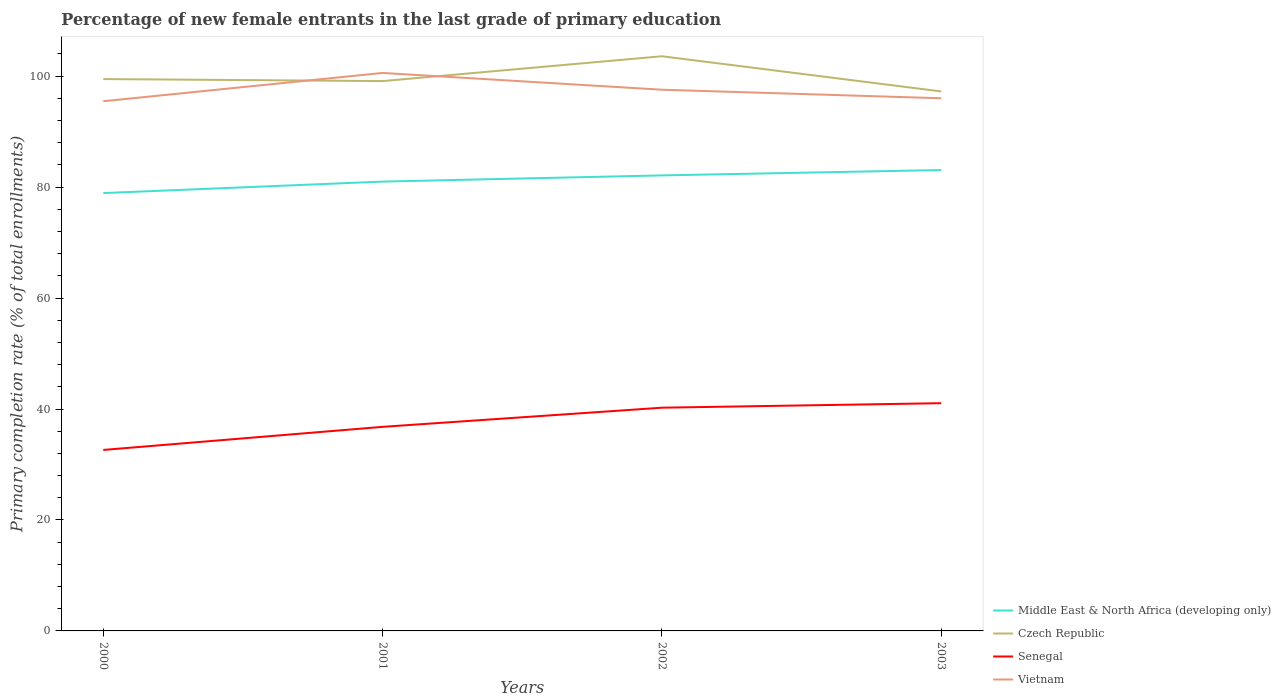How many different coloured lines are there?
Make the answer very short. 4. Is the number of lines equal to the number of legend labels?
Your response must be concise. Yes. Across all years, what is the maximum percentage of new female entrants in Czech Republic?
Offer a very short reply. 97.24. What is the total percentage of new female entrants in Vietnam in the graph?
Your response must be concise. -0.54. What is the difference between the highest and the second highest percentage of new female entrants in Senegal?
Your answer should be compact. 8.43. What is the difference between the highest and the lowest percentage of new female entrants in Senegal?
Your response must be concise. 2. How many lines are there?
Your answer should be compact. 4. How many years are there in the graph?
Your answer should be compact. 4. What is the difference between two consecutive major ticks on the Y-axis?
Your response must be concise. 20. Are the values on the major ticks of Y-axis written in scientific E-notation?
Your response must be concise. No. Does the graph contain any zero values?
Keep it short and to the point. No. What is the title of the graph?
Keep it short and to the point. Percentage of new female entrants in the last grade of primary education. Does "Northern Mariana Islands" appear as one of the legend labels in the graph?
Provide a short and direct response. No. What is the label or title of the X-axis?
Your answer should be very brief. Years. What is the label or title of the Y-axis?
Offer a very short reply. Primary completion rate (% of total enrollments). What is the Primary completion rate (% of total enrollments) in Middle East & North Africa (developing only) in 2000?
Ensure brevity in your answer.  78.92. What is the Primary completion rate (% of total enrollments) in Czech Republic in 2000?
Offer a terse response. 99.47. What is the Primary completion rate (% of total enrollments) of Senegal in 2000?
Keep it short and to the point. 32.62. What is the Primary completion rate (% of total enrollments) in Vietnam in 2000?
Your answer should be compact. 95.48. What is the Primary completion rate (% of total enrollments) of Middle East & North Africa (developing only) in 2001?
Provide a succinct answer. 80.99. What is the Primary completion rate (% of total enrollments) of Czech Republic in 2001?
Keep it short and to the point. 99.11. What is the Primary completion rate (% of total enrollments) of Senegal in 2001?
Provide a short and direct response. 36.78. What is the Primary completion rate (% of total enrollments) in Vietnam in 2001?
Your response must be concise. 100.58. What is the Primary completion rate (% of total enrollments) in Middle East & North Africa (developing only) in 2002?
Your response must be concise. 82.11. What is the Primary completion rate (% of total enrollments) of Czech Republic in 2002?
Ensure brevity in your answer.  103.58. What is the Primary completion rate (% of total enrollments) in Senegal in 2002?
Ensure brevity in your answer.  40.24. What is the Primary completion rate (% of total enrollments) of Vietnam in 2002?
Provide a succinct answer. 97.55. What is the Primary completion rate (% of total enrollments) in Middle East & North Africa (developing only) in 2003?
Provide a short and direct response. 83.07. What is the Primary completion rate (% of total enrollments) in Czech Republic in 2003?
Your answer should be compact. 97.24. What is the Primary completion rate (% of total enrollments) of Senegal in 2003?
Your answer should be very brief. 41.05. What is the Primary completion rate (% of total enrollments) in Vietnam in 2003?
Offer a terse response. 96.01. Across all years, what is the maximum Primary completion rate (% of total enrollments) in Middle East & North Africa (developing only)?
Keep it short and to the point. 83.07. Across all years, what is the maximum Primary completion rate (% of total enrollments) of Czech Republic?
Your response must be concise. 103.58. Across all years, what is the maximum Primary completion rate (% of total enrollments) of Senegal?
Offer a terse response. 41.05. Across all years, what is the maximum Primary completion rate (% of total enrollments) in Vietnam?
Your answer should be compact. 100.58. Across all years, what is the minimum Primary completion rate (% of total enrollments) in Middle East & North Africa (developing only)?
Make the answer very short. 78.92. Across all years, what is the minimum Primary completion rate (% of total enrollments) in Czech Republic?
Provide a succinct answer. 97.24. Across all years, what is the minimum Primary completion rate (% of total enrollments) in Senegal?
Your answer should be very brief. 32.62. Across all years, what is the minimum Primary completion rate (% of total enrollments) in Vietnam?
Your answer should be very brief. 95.48. What is the total Primary completion rate (% of total enrollments) of Middle East & North Africa (developing only) in the graph?
Keep it short and to the point. 325.1. What is the total Primary completion rate (% of total enrollments) in Czech Republic in the graph?
Make the answer very short. 399.41. What is the total Primary completion rate (% of total enrollments) in Senegal in the graph?
Make the answer very short. 150.69. What is the total Primary completion rate (% of total enrollments) in Vietnam in the graph?
Ensure brevity in your answer.  389.62. What is the difference between the Primary completion rate (% of total enrollments) of Middle East & North Africa (developing only) in 2000 and that in 2001?
Offer a very short reply. -2.07. What is the difference between the Primary completion rate (% of total enrollments) of Czech Republic in 2000 and that in 2001?
Offer a terse response. 0.36. What is the difference between the Primary completion rate (% of total enrollments) in Senegal in 2000 and that in 2001?
Give a very brief answer. -4.16. What is the difference between the Primary completion rate (% of total enrollments) of Vietnam in 2000 and that in 2001?
Ensure brevity in your answer.  -5.1. What is the difference between the Primary completion rate (% of total enrollments) in Middle East & North Africa (developing only) in 2000 and that in 2002?
Offer a very short reply. -3.19. What is the difference between the Primary completion rate (% of total enrollments) in Czech Republic in 2000 and that in 2002?
Give a very brief answer. -4.11. What is the difference between the Primary completion rate (% of total enrollments) in Senegal in 2000 and that in 2002?
Give a very brief answer. -7.61. What is the difference between the Primary completion rate (% of total enrollments) of Vietnam in 2000 and that in 2002?
Provide a succinct answer. -2.08. What is the difference between the Primary completion rate (% of total enrollments) of Middle East & North Africa (developing only) in 2000 and that in 2003?
Your answer should be compact. -4.15. What is the difference between the Primary completion rate (% of total enrollments) of Czech Republic in 2000 and that in 2003?
Offer a terse response. 2.23. What is the difference between the Primary completion rate (% of total enrollments) in Senegal in 2000 and that in 2003?
Your answer should be very brief. -8.43. What is the difference between the Primary completion rate (% of total enrollments) in Vietnam in 2000 and that in 2003?
Your answer should be very brief. -0.54. What is the difference between the Primary completion rate (% of total enrollments) in Middle East & North Africa (developing only) in 2001 and that in 2002?
Your answer should be compact. -1.12. What is the difference between the Primary completion rate (% of total enrollments) of Czech Republic in 2001 and that in 2002?
Ensure brevity in your answer.  -4.47. What is the difference between the Primary completion rate (% of total enrollments) of Senegal in 2001 and that in 2002?
Provide a succinct answer. -3.45. What is the difference between the Primary completion rate (% of total enrollments) of Vietnam in 2001 and that in 2002?
Offer a very short reply. 3.02. What is the difference between the Primary completion rate (% of total enrollments) of Middle East & North Africa (developing only) in 2001 and that in 2003?
Ensure brevity in your answer.  -2.08. What is the difference between the Primary completion rate (% of total enrollments) in Czech Republic in 2001 and that in 2003?
Offer a terse response. 1.87. What is the difference between the Primary completion rate (% of total enrollments) in Senegal in 2001 and that in 2003?
Make the answer very short. -4.26. What is the difference between the Primary completion rate (% of total enrollments) in Vietnam in 2001 and that in 2003?
Provide a succinct answer. 4.56. What is the difference between the Primary completion rate (% of total enrollments) in Middle East & North Africa (developing only) in 2002 and that in 2003?
Provide a short and direct response. -0.96. What is the difference between the Primary completion rate (% of total enrollments) of Czech Republic in 2002 and that in 2003?
Make the answer very short. 6.34. What is the difference between the Primary completion rate (% of total enrollments) of Senegal in 2002 and that in 2003?
Give a very brief answer. -0.81. What is the difference between the Primary completion rate (% of total enrollments) of Vietnam in 2002 and that in 2003?
Make the answer very short. 1.54. What is the difference between the Primary completion rate (% of total enrollments) of Middle East & North Africa (developing only) in 2000 and the Primary completion rate (% of total enrollments) of Czech Republic in 2001?
Offer a terse response. -20.19. What is the difference between the Primary completion rate (% of total enrollments) of Middle East & North Africa (developing only) in 2000 and the Primary completion rate (% of total enrollments) of Senegal in 2001?
Offer a very short reply. 42.14. What is the difference between the Primary completion rate (% of total enrollments) in Middle East & North Africa (developing only) in 2000 and the Primary completion rate (% of total enrollments) in Vietnam in 2001?
Make the answer very short. -21.66. What is the difference between the Primary completion rate (% of total enrollments) in Czech Republic in 2000 and the Primary completion rate (% of total enrollments) in Senegal in 2001?
Offer a terse response. 62.69. What is the difference between the Primary completion rate (% of total enrollments) of Czech Republic in 2000 and the Primary completion rate (% of total enrollments) of Vietnam in 2001?
Provide a succinct answer. -1.1. What is the difference between the Primary completion rate (% of total enrollments) in Senegal in 2000 and the Primary completion rate (% of total enrollments) in Vietnam in 2001?
Provide a succinct answer. -67.95. What is the difference between the Primary completion rate (% of total enrollments) in Middle East & North Africa (developing only) in 2000 and the Primary completion rate (% of total enrollments) in Czech Republic in 2002?
Give a very brief answer. -24.66. What is the difference between the Primary completion rate (% of total enrollments) in Middle East & North Africa (developing only) in 2000 and the Primary completion rate (% of total enrollments) in Senegal in 2002?
Your answer should be compact. 38.68. What is the difference between the Primary completion rate (% of total enrollments) in Middle East & North Africa (developing only) in 2000 and the Primary completion rate (% of total enrollments) in Vietnam in 2002?
Ensure brevity in your answer.  -18.63. What is the difference between the Primary completion rate (% of total enrollments) in Czech Republic in 2000 and the Primary completion rate (% of total enrollments) in Senegal in 2002?
Keep it short and to the point. 59.24. What is the difference between the Primary completion rate (% of total enrollments) of Czech Republic in 2000 and the Primary completion rate (% of total enrollments) of Vietnam in 2002?
Make the answer very short. 1.92. What is the difference between the Primary completion rate (% of total enrollments) of Senegal in 2000 and the Primary completion rate (% of total enrollments) of Vietnam in 2002?
Offer a very short reply. -64.93. What is the difference between the Primary completion rate (% of total enrollments) of Middle East & North Africa (developing only) in 2000 and the Primary completion rate (% of total enrollments) of Czech Republic in 2003?
Provide a short and direct response. -18.32. What is the difference between the Primary completion rate (% of total enrollments) in Middle East & North Africa (developing only) in 2000 and the Primary completion rate (% of total enrollments) in Senegal in 2003?
Offer a very short reply. 37.87. What is the difference between the Primary completion rate (% of total enrollments) in Middle East & North Africa (developing only) in 2000 and the Primary completion rate (% of total enrollments) in Vietnam in 2003?
Provide a short and direct response. -17.09. What is the difference between the Primary completion rate (% of total enrollments) in Czech Republic in 2000 and the Primary completion rate (% of total enrollments) in Senegal in 2003?
Your response must be concise. 58.43. What is the difference between the Primary completion rate (% of total enrollments) of Czech Republic in 2000 and the Primary completion rate (% of total enrollments) of Vietnam in 2003?
Provide a short and direct response. 3.46. What is the difference between the Primary completion rate (% of total enrollments) in Senegal in 2000 and the Primary completion rate (% of total enrollments) in Vietnam in 2003?
Offer a terse response. -63.39. What is the difference between the Primary completion rate (% of total enrollments) in Middle East & North Africa (developing only) in 2001 and the Primary completion rate (% of total enrollments) in Czech Republic in 2002?
Your response must be concise. -22.59. What is the difference between the Primary completion rate (% of total enrollments) in Middle East & North Africa (developing only) in 2001 and the Primary completion rate (% of total enrollments) in Senegal in 2002?
Make the answer very short. 40.76. What is the difference between the Primary completion rate (% of total enrollments) of Middle East & North Africa (developing only) in 2001 and the Primary completion rate (% of total enrollments) of Vietnam in 2002?
Ensure brevity in your answer.  -16.56. What is the difference between the Primary completion rate (% of total enrollments) in Czech Republic in 2001 and the Primary completion rate (% of total enrollments) in Senegal in 2002?
Ensure brevity in your answer.  58.87. What is the difference between the Primary completion rate (% of total enrollments) of Czech Republic in 2001 and the Primary completion rate (% of total enrollments) of Vietnam in 2002?
Make the answer very short. 1.56. What is the difference between the Primary completion rate (% of total enrollments) of Senegal in 2001 and the Primary completion rate (% of total enrollments) of Vietnam in 2002?
Give a very brief answer. -60.77. What is the difference between the Primary completion rate (% of total enrollments) in Middle East & North Africa (developing only) in 2001 and the Primary completion rate (% of total enrollments) in Czech Republic in 2003?
Your response must be concise. -16.25. What is the difference between the Primary completion rate (% of total enrollments) of Middle East & North Africa (developing only) in 2001 and the Primary completion rate (% of total enrollments) of Senegal in 2003?
Your response must be concise. 39.94. What is the difference between the Primary completion rate (% of total enrollments) of Middle East & North Africa (developing only) in 2001 and the Primary completion rate (% of total enrollments) of Vietnam in 2003?
Ensure brevity in your answer.  -15.02. What is the difference between the Primary completion rate (% of total enrollments) in Czech Republic in 2001 and the Primary completion rate (% of total enrollments) in Senegal in 2003?
Your answer should be very brief. 58.06. What is the difference between the Primary completion rate (% of total enrollments) in Czech Republic in 2001 and the Primary completion rate (% of total enrollments) in Vietnam in 2003?
Make the answer very short. 3.1. What is the difference between the Primary completion rate (% of total enrollments) of Senegal in 2001 and the Primary completion rate (% of total enrollments) of Vietnam in 2003?
Offer a terse response. -59.23. What is the difference between the Primary completion rate (% of total enrollments) in Middle East & North Africa (developing only) in 2002 and the Primary completion rate (% of total enrollments) in Czech Republic in 2003?
Make the answer very short. -15.13. What is the difference between the Primary completion rate (% of total enrollments) in Middle East & North Africa (developing only) in 2002 and the Primary completion rate (% of total enrollments) in Senegal in 2003?
Keep it short and to the point. 41.06. What is the difference between the Primary completion rate (% of total enrollments) in Middle East & North Africa (developing only) in 2002 and the Primary completion rate (% of total enrollments) in Vietnam in 2003?
Offer a very short reply. -13.9. What is the difference between the Primary completion rate (% of total enrollments) of Czech Republic in 2002 and the Primary completion rate (% of total enrollments) of Senegal in 2003?
Ensure brevity in your answer.  62.54. What is the difference between the Primary completion rate (% of total enrollments) in Czech Republic in 2002 and the Primary completion rate (% of total enrollments) in Vietnam in 2003?
Make the answer very short. 7.57. What is the difference between the Primary completion rate (% of total enrollments) in Senegal in 2002 and the Primary completion rate (% of total enrollments) in Vietnam in 2003?
Provide a short and direct response. -55.78. What is the average Primary completion rate (% of total enrollments) of Middle East & North Africa (developing only) per year?
Your response must be concise. 81.28. What is the average Primary completion rate (% of total enrollments) in Czech Republic per year?
Your answer should be very brief. 99.85. What is the average Primary completion rate (% of total enrollments) in Senegal per year?
Keep it short and to the point. 37.67. What is the average Primary completion rate (% of total enrollments) in Vietnam per year?
Ensure brevity in your answer.  97.41. In the year 2000, what is the difference between the Primary completion rate (% of total enrollments) in Middle East & North Africa (developing only) and Primary completion rate (% of total enrollments) in Czech Republic?
Make the answer very short. -20.55. In the year 2000, what is the difference between the Primary completion rate (% of total enrollments) of Middle East & North Africa (developing only) and Primary completion rate (% of total enrollments) of Senegal?
Keep it short and to the point. 46.3. In the year 2000, what is the difference between the Primary completion rate (% of total enrollments) of Middle East & North Africa (developing only) and Primary completion rate (% of total enrollments) of Vietnam?
Give a very brief answer. -16.56. In the year 2000, what is the difference between the Primary completion rate (% of total enrollments) in Czech Republic and Primary completion rate (% of total enrollments) in Senegal?
Give a very brief answer. 66.85. In the year 2000, what is the difference between the Primary completion rate (% of total enrollments) in Czech Republic and Primary completion rate (% of total enrollments) in Vietnam?
Ensure brevity in your answer.  4. In the year 2000, what is the difference between the Primary completion rate (% of total enrollments) of Senegal and Primary completion rate (% of total enrollments) of Vietnam?
Offer a terse response. -62.86. In the year 2001, what is the difference between the Primary completion rate (% of total enrollments) in Middle East & North Africa (developing only) and Primary completion rate (% of total enrollments) in Czech Republic?
Offer a very short reply. -18.12. In the year 2001, what is the difference between the Primary completion rate (% of total enrollments) of Middle East & North Africa (developing only) and Primary completion rate (% of total enrollments) of Senegal?
Offer a very short reply. 44.21. In the year 2001, what is the difference between the Primary completion rate (% of total enrollments) in Middle East & North Africa (developing only) and Primary completion rate (% of total enrollments) in Vietnam?
Ensure brevity in your answer.  -19.58. In the year 2001, what is the difference between the Primary completion rate (% of total enrollments) of Czech Republic and Primary completion rate (% of total enrollments) of Senegal?
Your answer should be very brief. 62.32. In the year 2001, what is the difference between the Primary completion rate (% of total enrollments) of Czech Republic and Primary completion rate (% of total enrollments) of Vietnam?
Provide a short and direct response. -1.47. In the year 2001, what is the difference between the Primary completion rate (% of total enrollments) of Senegal and Primary completion rate (% of total enrollments) of Vietnam?
Provide a succinct answer. -63.79. In the year 2002, what is the difference between the Primary completion rate (% of total enrollments) in Middle East & North Africa (developing only) and Primary completion rate (% of total enrollments) in Czech Republic?
Offer a terse response. -21.47. In the year 2002, what is the difference between the Primary completion rate (% of total enrollments) in Middle East & North Africa (developing only) and Primary completion rate (% of total enrollments) in Senegal?
Your answer should be very brief. 41.87. In the year 2002, what is the difference between the Primary completion rate (% of total enrollments) of Middle East & North Africa (developing only) and Primary completion rate (% of total enrollments) of Vietnam?
Your response must be concise. -15.44. In the year 2002, what is the difference between the Primary completion rate (% of total enrollments) in Czech Republic and Primary completion rate (% of total enrollments) in Senegal?
Your answer should be compact. 63.35. In the year 2002, what is the difference between the Primary completion rate (% of total enrollments) in Czech Republic and Primary completion rate (% of total enrollments) in Vietnam?
Your response must be concise. 6.03. In the year 2002, what is the difference between the Primary completion rate (% of total enrollments) of Senegal and Primary completion rate (% of total enrollments) of Vietnam?
Ensure brevity in your answer.  -57.32. In the year 2003, what is the difference between the Primary completion rate (% of total enrollments) in Middle East & North Africa (developing only) and Primary completion rate (% of total enrollments) in Czech Republic?
Your answer should be very brief. -14.17. In the year 2003, what is the difference between the Primary completion rate (% of total enrollments) of Middle East & North Africa (developing only) and Primary completion rate (% of total enrollments) of Senegal?
Keep it short and to the point. 42.03. In the year 2003, what is the difference between the Primary completion rate (% of total enrollments) in Middle East & North Africa (developing only) and Primary completion rate (% of total enrollments) in Vietnam?
Give a very brief answer. -12.94. In the year 2003, what is the difference between the Primary completion rate (% of total enrollments) of Czech Republic and Primary completion rate (% of total enrollments) of Senegal?
Ensure brevity in your answer.  56.19. In the year 2003, what is the difference between the Primary completion rate (% of total enrollments) in Czech Republic and Primary completion rate (% of total enrollments) in Vietnam?
Your response must be concise. 1.23. In the year 2003, what is the difference between the Primary completion rate (% of total enrollments) of Senegal and Primary completion rate (% of total enrollments) of Vietnam?
Your response must be concise. -54.96. What is the ratio of the Primary completion rate (% of total enrollments) of Middle East & North Africa (developing only) in 2000 to that in 2001?
Offer a terse response. 0.97. What is the ratio of the Primary completion rate (% of total enrollments) in Czech Republic in 2000 to that in 2001?
Make the answer very short. 1. What is the ratio of the Primary completion rate (% of total enrollments) of Senegal in 2000 to that in 2001?
Your response must be concise. 0.89. What is the ratio of the Primary completion rate (% of total enrollments) of Vietnam in 2000 to that in 2001?
Keep it short and to the point. 0.95. What is the ratio of the Primary completion rate (% of total enrollments) of Middle East & North Africa (developing only) in 2000 to that in 2002?
Offer a terse response. 0.96. What is the ratio of the Primary completion rate (% of total enrollments) in Czech Republic in 2000 to that in 2002?
Provide a succinct answer. 0.96. What is the ratio of the Primary completion rate (% of total enrollments) in Senegal in 2000 to that in 2002?
Keep it short and to the point. 0.81. What is the ratio of the Primary completion rate (% of total enrollments) of Vietnam in 2000 to that in 2002?
Make the answer very short. 0.98. What is the ratio of the Primary completion rate (% of total enrollments) of Czech Republic in 2000 to that in 2003?
Provide a succinct answer. 1.02. What is the ratio of the Primary completion rate (% of total enrollments) of Senegal in 2000 to that in 2003?
Your answer should be compact. 0.79. What is the ratio of the Primary completion rate (% of total enrollments) in Middle East & North Africa (developing only) in 2001 to that in 2002?
Your answer should be compact. 0.99. What is the ratio of the Primary completion rate (% of total enrollments) in Czech Republic in 2001 to that in 2002?
Ensure brevity in your answer.  0.96. What is the ratio of the Primary completion rate (% of total enrollments) in Senegal in 2001 to that in 2002?
Ensure brevity in your answer.  0.91. What is the ratio of the Primary completion rate (% of total enrollments) in Vietnam in 2001 to that in 2002?
Offer a terse response. 1.03. What is the ratio of the Primary completion rate (% of total enrollments) of Middle East & North Africa (developing only) in 2001 to that in 2003?
Offer a very short reply. 0.97. What is the ratio of the Primary completion rate (% of total enrollments) of Czech Republic in 2001 to that in 2003?
Offer a terse response. 1.02. What is the ratio of the Primary completion rate (% of total enrollments) of Senegal in 2001 to that in 2003?
Offer a terse response. 0.9. What is the ratio of the Primary completion rate (% of total enrollments) of Vietnam in 2001 to that in 2003?
Keep it short and to the point. 1.05. What is the ratio of the Primary completion rate (% of total enrollments) of Middle East & North Africa (developing only) in 2002 to that in 2003?
Provide a short and direct response. 0.99. What is the ratio of the Primary completion rate (% of total enrollments) of Czech Republic in 2002 to that in 2003?
Provide a succinct answer. 1.07. What is the ratio of the Primary completion rate (% of total enrollments) in Senegal in 2002 to that in 2003?
Offer a very short reply. 0.98. What is the ratio of the Primary completion rate (% of total enrollments) in Vietnam in 2002 to that in 2003?
Keep it short and to the point. 1.02. What is the difference between the highest and the second highest Primary completion rate (% of total enrollments) in Middle East & North Africa (developing only)?
Provide a succinct answer. 0.96. What is the difference between the highest and the second highest Primary completion rate (% of total enrollments) of Czech Republic?
Your response must be concise. 4.11. What is the difference between the highest and the second highest Primary completion rate (% of total enrollments) of Senegal?
Ensure brevity in your answer.  0.81. What is the difference between the highest and the second highest Primary completion rate (% of total enrollments) in Vietnam?
Give a very brief answer. 3.02. What is the difference between the highest and the lowest Primary completion rate (% of total enrollments) in Middle East & North Africa (developing only)?
Make the answer very short. 4.15. What is the difference between the highest and the lowest Primary completion rate (% of total enrollments) in Czech Republic?
Keep it short and to the point. 6.34. What is the difference between the highest and the lowest Primary completion rate (% of total enrollments) of Senegal?
Ensure brevity in your answer.  8.43. What is the difference between the highest and the lowest Primary completion rate (% of total enrollments) of Vietnam?
Ensure brevity in your answer.  5.1. 